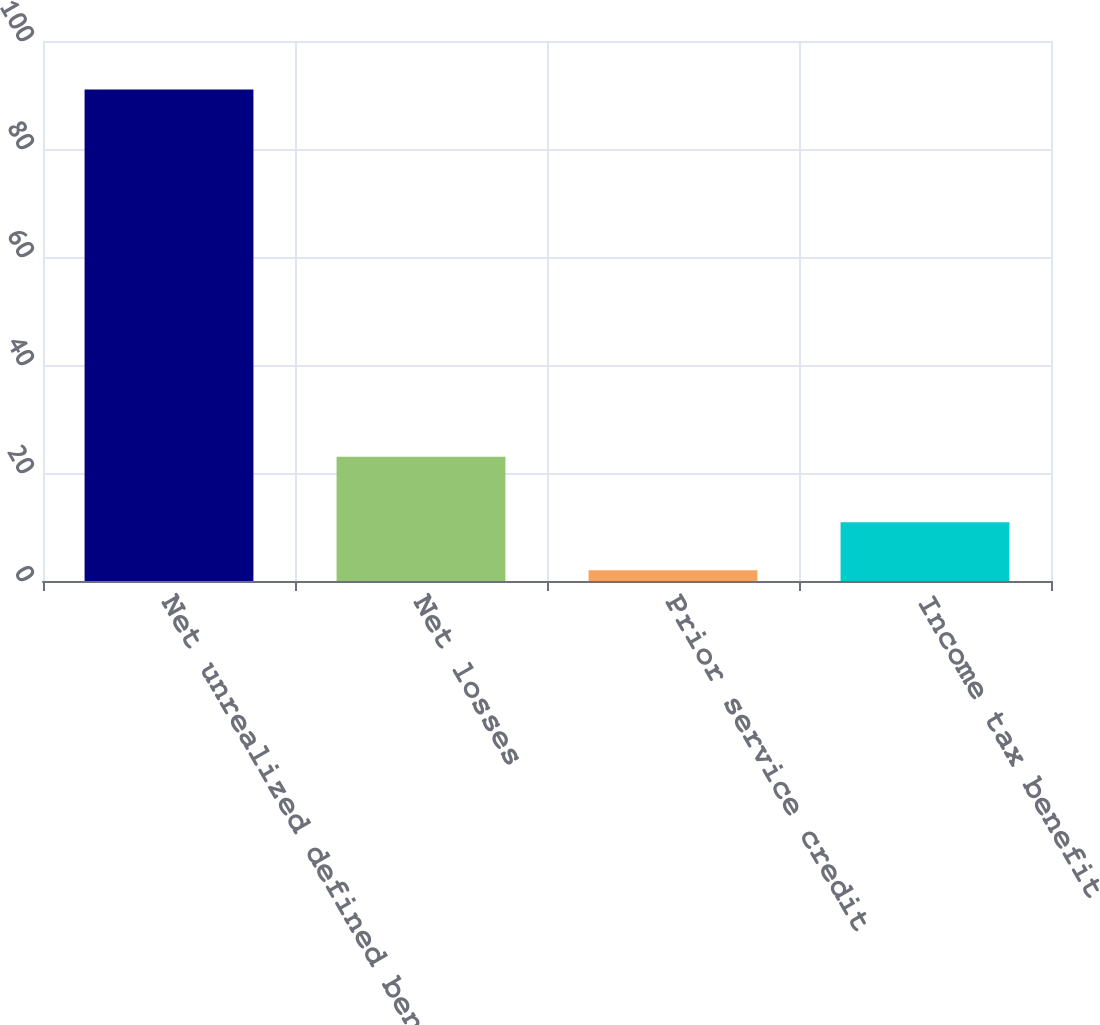Convert chart to OTSL. <chart><loc_0><loc_0><loc_500><loc_500><bar_chart><fcel>Net unrealized defined benefit<fcel>Net losses<fcel>Prior service credit<fcel>Income tax benefit<nl><fcel>91<fcel>23<fcel>2<fcel>10.9<nl></chart> 